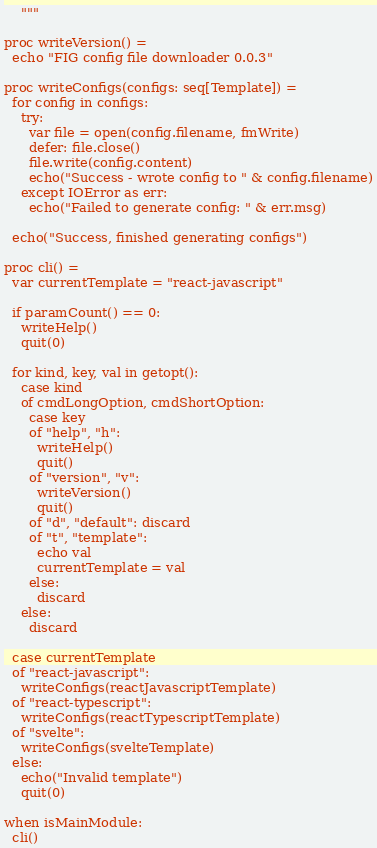<code> <loc_0><loc_0><loc_500><loc_500><_Nim_>    """

proc writeVersion() =
  echo "FIG config file downloader 0.0.3"

proc writeConfigs(configs: seq[Template]) =
  for config in configs:
    try:
      var file = open(config.filename, fmWrite)
      defer: file.close()
      file.write(config.content)
      echo("Success - wrote config to " & config.filename)
    except IOError as err:
      echo("Failed to generate config: " & err.msg)

  echo("Success, finished generating configs")

proc cli() =
  var currentTemplate = "react-javascript"

  if paramCount() == 0:
    writeHelp()
    quit(0)

  for kind, key, val in getopt():
    case kind
    of cmdLongOption, cmdShortOption:
      case key
      of "help", "h":
        writeHelp()
        quit()
      of "version", "v":
        writeVersion()
        quit()
      of "d", "default": discard
      of "t", "template":
        echo val
        currentTemplate = val
      else:
        discard
    else:
      discard

  case currentTemplate
  of "react-javascript":
    writeConfigs(reactJavascriptTemplate)
  of "react-typescript":
    writeConfigs(reactTypescriptTemplate)
  of "svelte":
    writeConfigs(svelteTemplate)
  else:
    echo("Invalid template")
    quit(0)

when isMainModule:
  cli()
</code> 